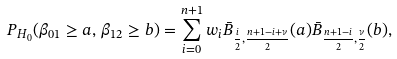<formula> <loc_0><loc_0><loc_500><loc_500>P _ { H _ { 0 } } ( \beta _ { 0 1 } \geq a , \, \beta _ { 1 2 } \geq b ) = \sum _ { i = 0 } ^ { n + 1 } w _ { i } \bar { B } _ { \frac { i } { 2 } , \frac { n + 1 - i + \nu } { 2 } } ( a ) \bar { B } _ { \frac { n + 1 - i } { 2 } , \frac { \nu } { 2 } } ( b ) ,</formula> 